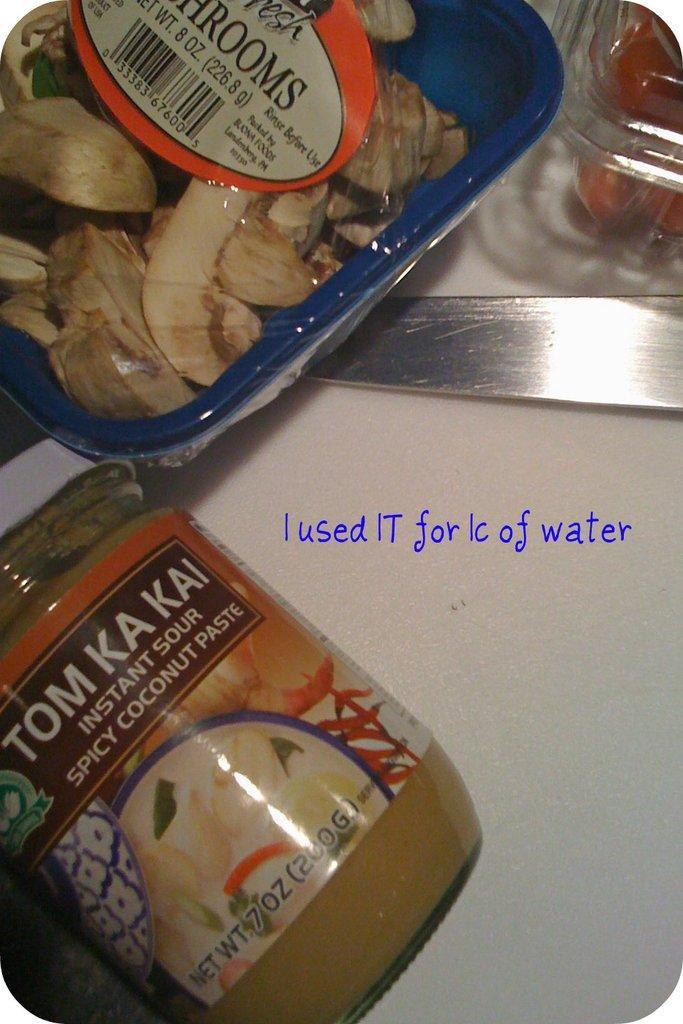Can you describe this image briefly? In this image we can see a jar, box and knife on the table. 